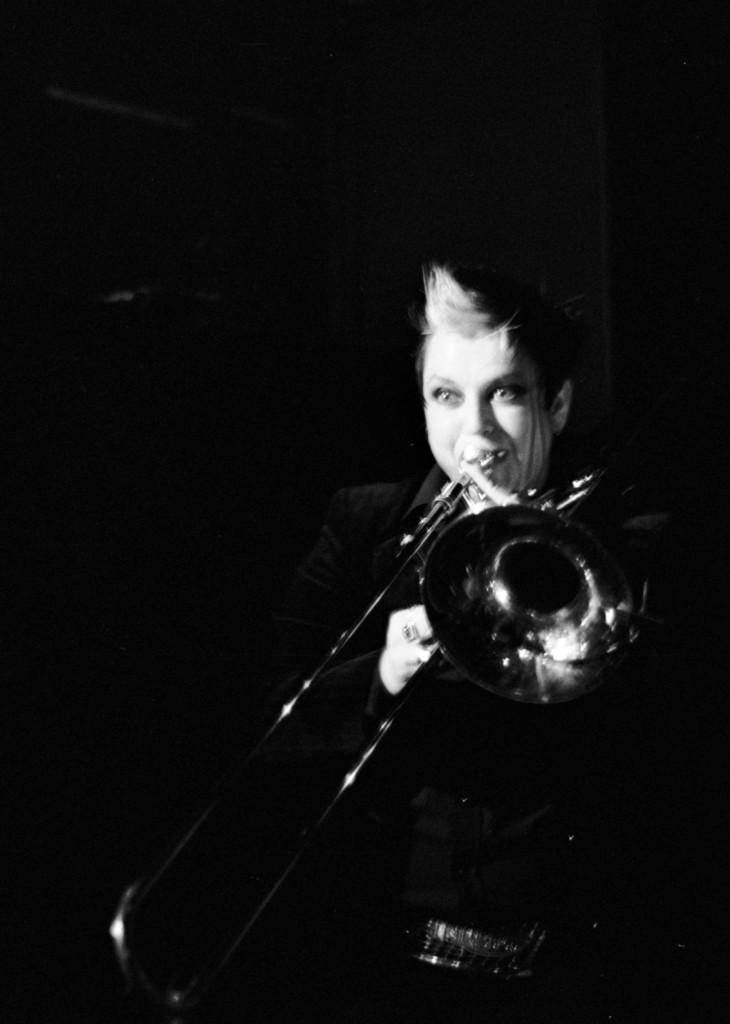Who is the main subject in the image? There is a woman in the image. What is the woman doing in the image? The woman is playing a musical instrument. Can you describe the background of the image? The background of the image is dark. Can you see any grass or water in the image? No, there is no grass or water present in the image. 